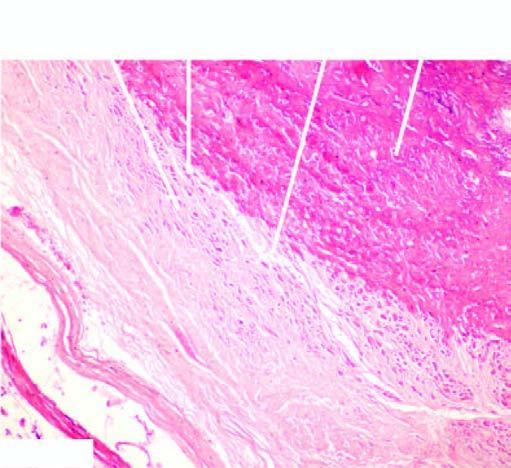do two daughter cells show osseous metaplasia in the centre?
Answer the question using a single word or phrase. No 